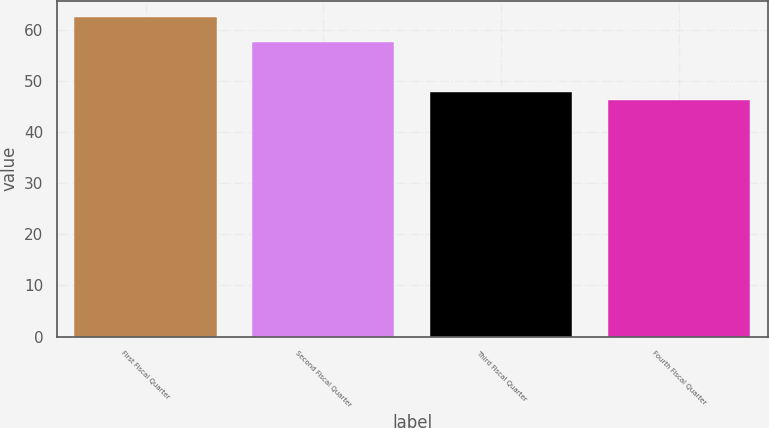Convert chart to OTSL. <chart><loc_0><loc_0><loc_500><loc_500><bar_chart><fcel>First Fiscal Quarter<fcel>Second Fiscal Quarter<fcel>Third Fiscal Quarter<fcel>Fourth Fiscal Quarter<nl><fcel>62.46<fcel>57.54<fcel>47.89<fcel>46.27<nl></chart> 